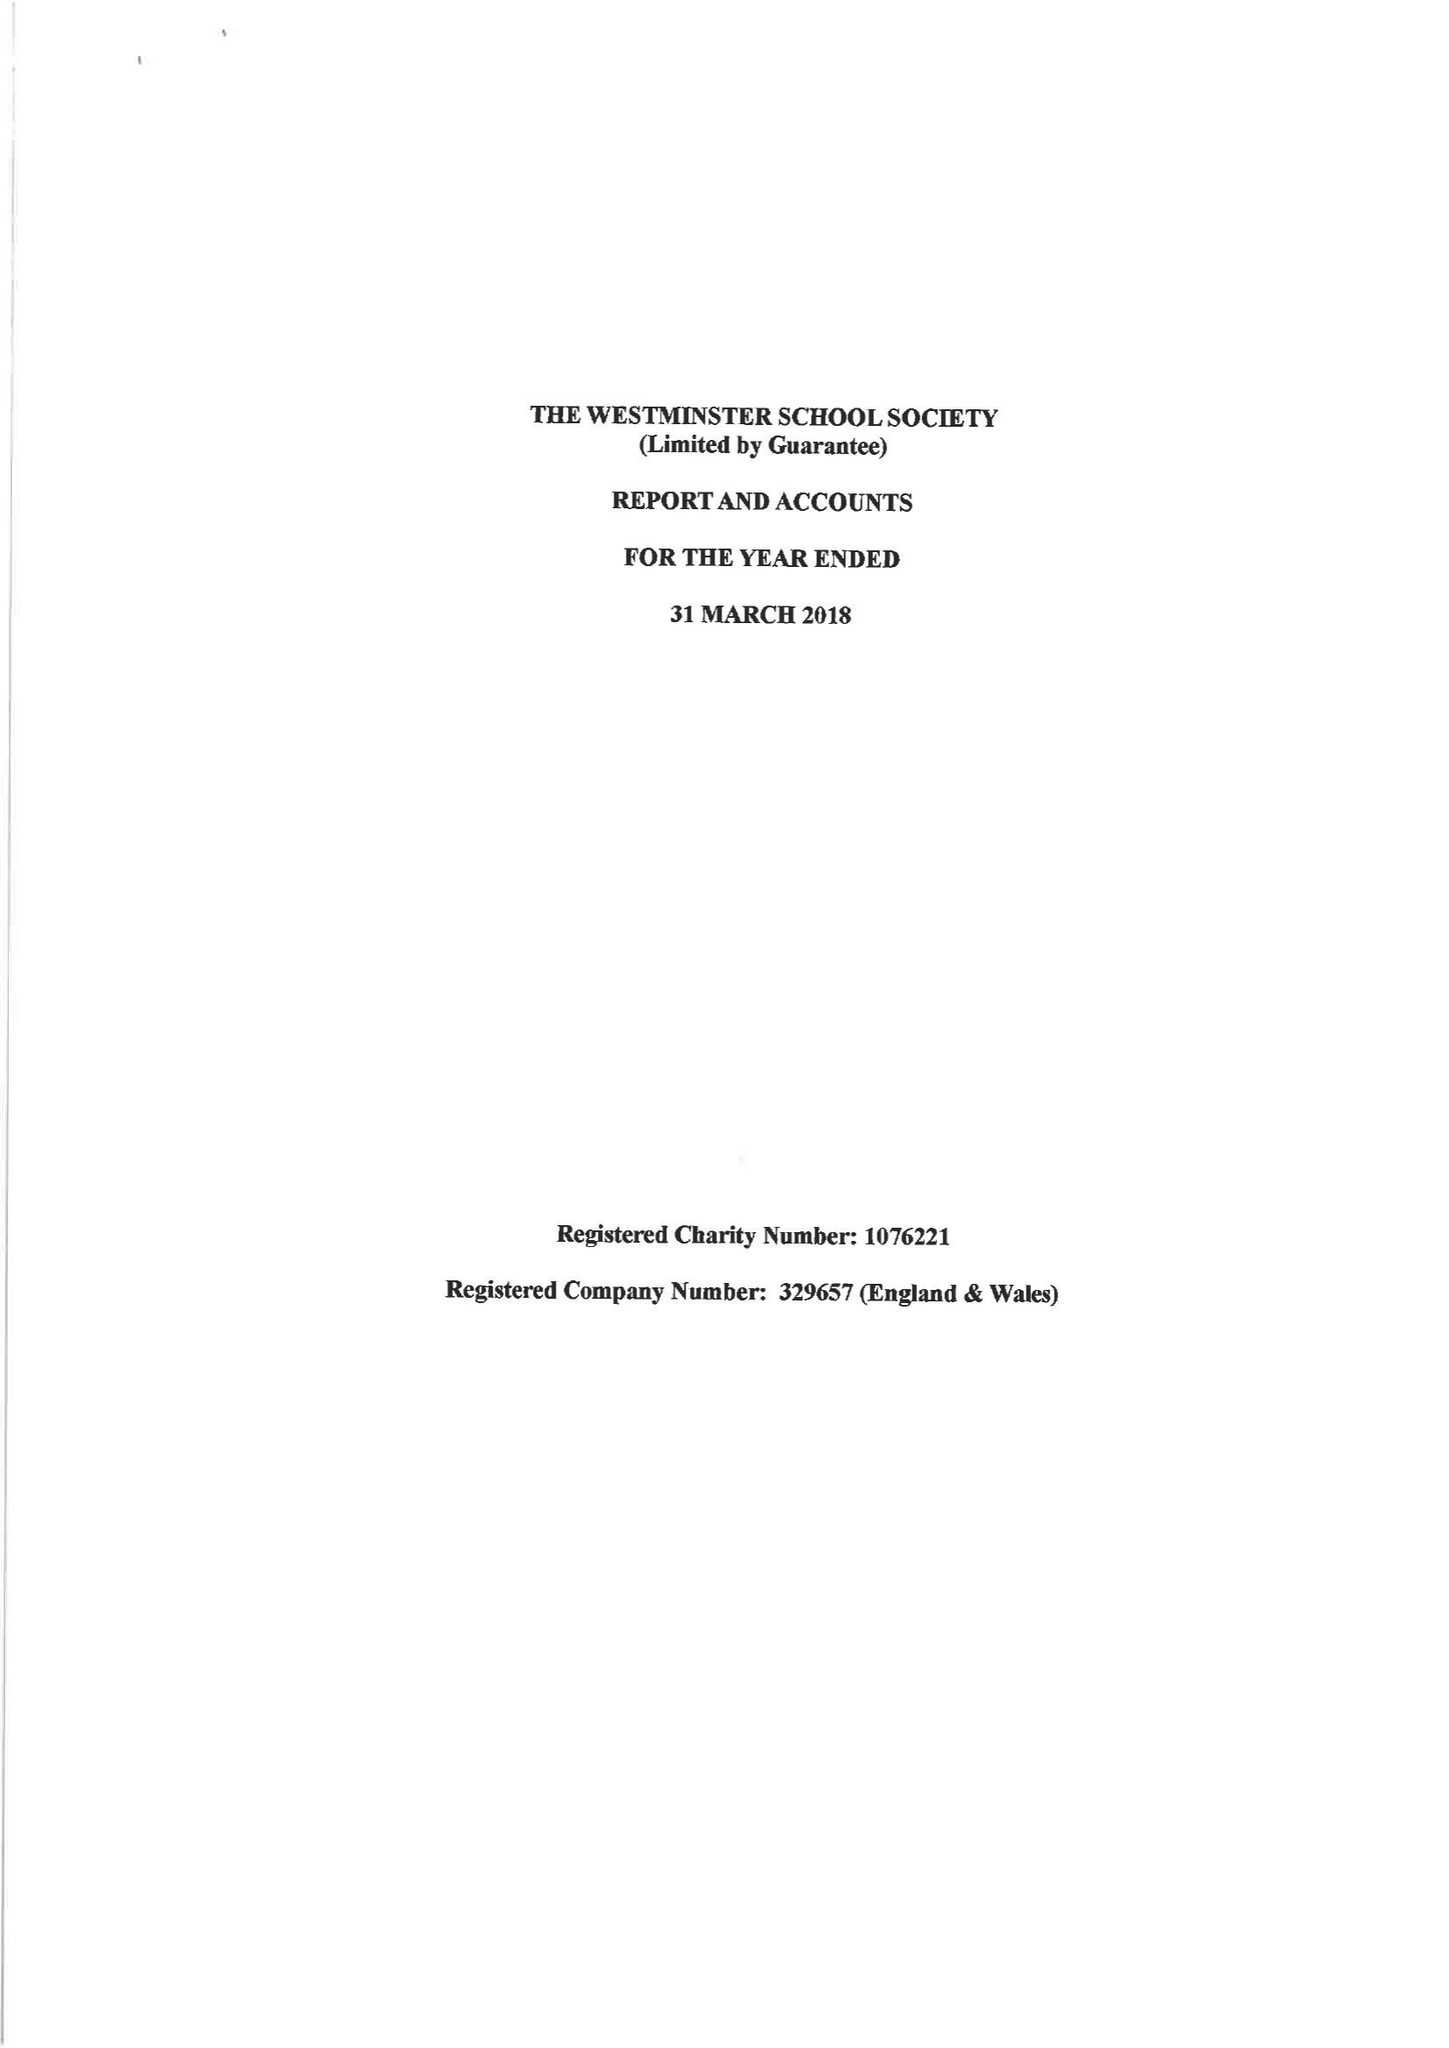What is the value for the report_date?
Answer the question using a single word or phrase. 2018-03-31 